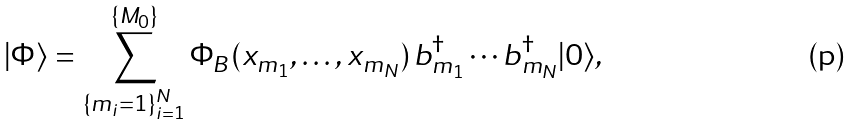<formula> <loc_0><loc_0><loc_500><loc_500>| \Phi \rangle = \sum _ { \{ m _ { i } = 1 \} _ { i = 1 } ^ { N } } ^ { \{ M _ { 0 } \} } \Phi _ { B } ( x _ { m _ { 1 } } , \dots , x _ { m _ { N } } ) \, b ^ { \dag } _ { m _ { 1 } } \cdots b ^ { \dag } _ { m _ { N } } | 0 \rangle ,</formula> 